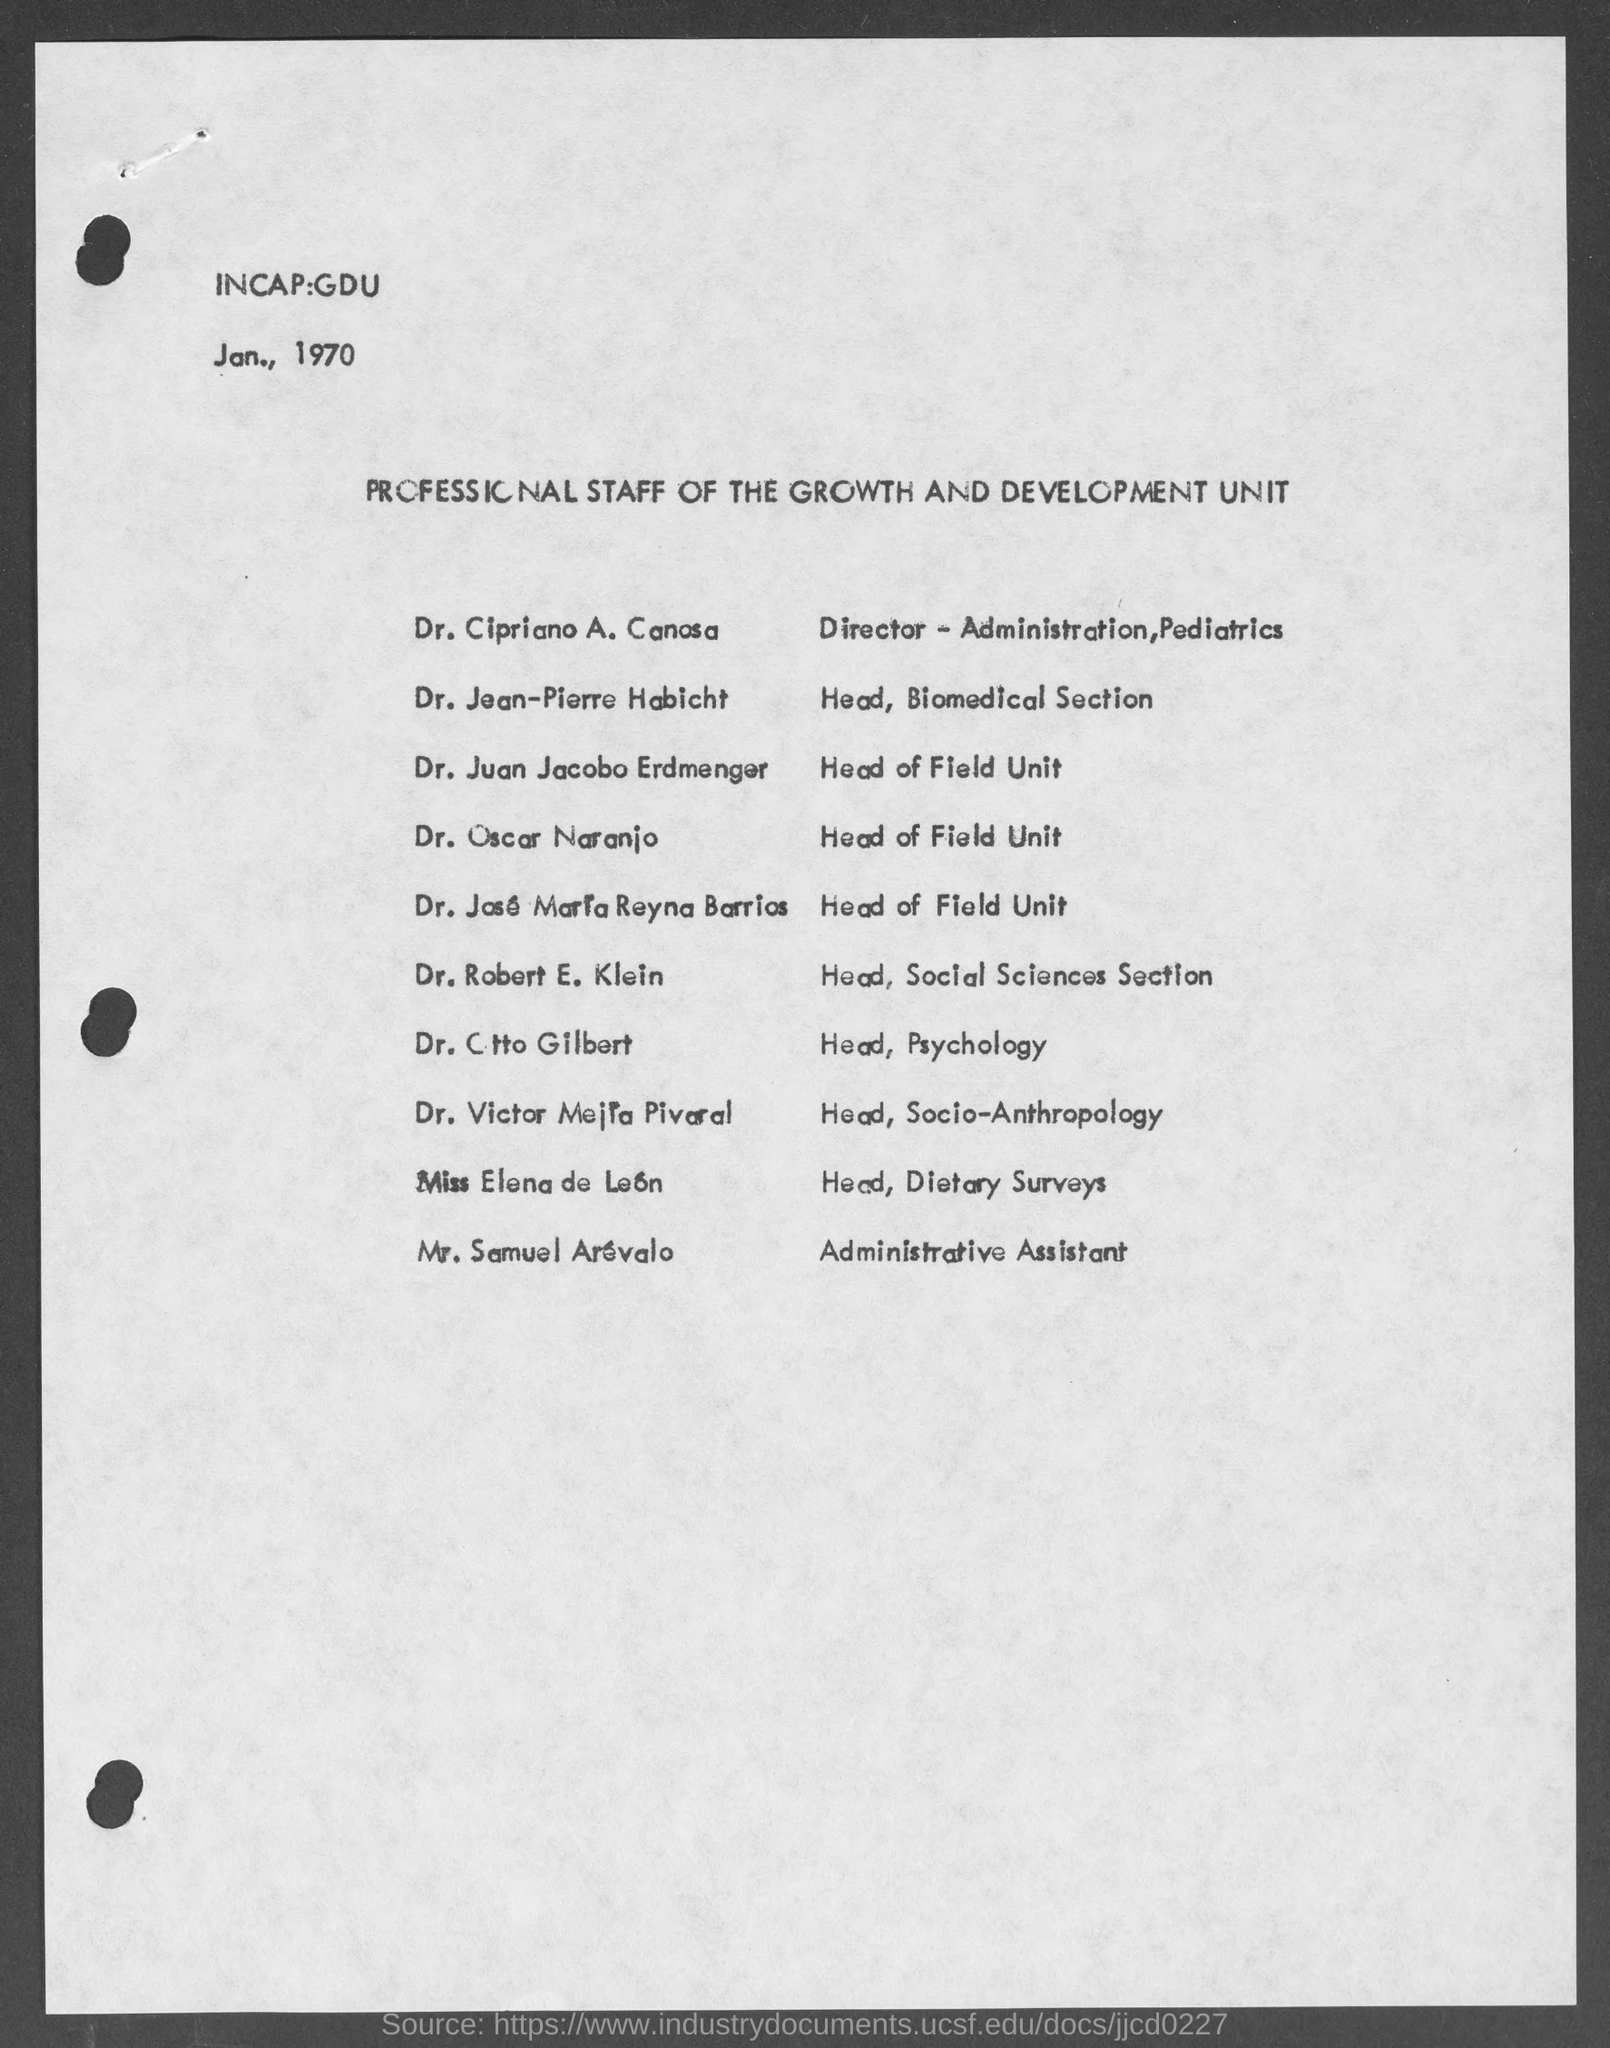Highlight a few significant elements in this photo. The given document is about the professional staff of the Growth and Development Unit. Dr. Cipriano A. Canosa is the Director of Administration and Pediatrics at a specified location. The date mentioned is January 1970. The administrative assistant is Mr. Samuel Arevalo. Dr. Cttò Gilbert is the head of psychology. 